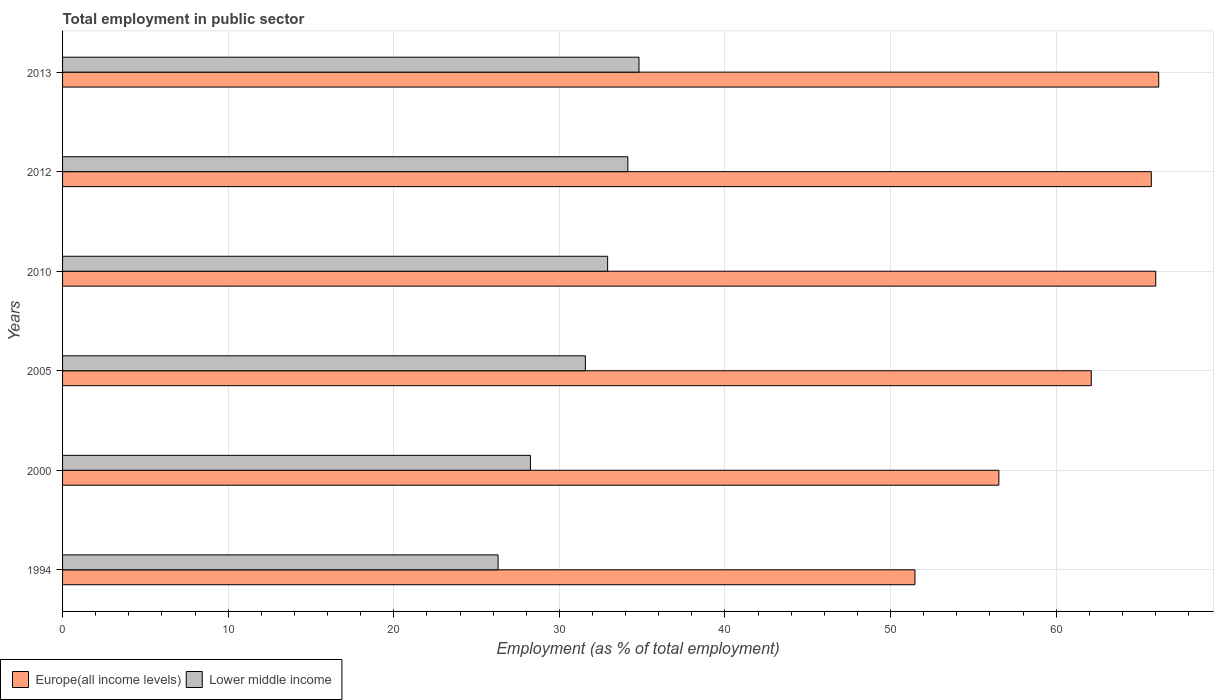How many groups of bars are there?
Make the answer very short. 6. Are the number of bars per tick equal to the number of legend labels?
Your answer should be compact. Yes. What is the employment in public sector in Europe(all income levels) in 2005?
Keep it short and to the point. 62.12. Across all years, what is the maximum employment in public sector in Europe(all income levels)?
Offer a terse response. 66.19. Across all years, what is the minimum employment in public sector in Europe(all income levels)?
Give a very brief answer. 51.47. In which year was the employment in public sector in Lower middle income maximum?
Provide a succinct answer. 2013. What is the total employment in public sector in Europe(all income levels) in the graph?
Provide a succinct answer. 368.09. What is the difference between the employment in public sector in Europe(all income levels) in 2000 and that in 2010?
Offer a terse response. -9.47. What is the difference between the employment in public sector in Europe(all income levels) in 2000 and the employment in public sector in Lower middle income in 2012?
Make the answer very short. 22.41. What is the average employment in public sector in Lower middle income per year?
Your response must be concise. 31.33. In the year 1994, what is the difference between the employment in public sector in Europe(all income levels) and employment in public sector in Lower middle income?
Make the answer very short. 25.17. What is the ratio of the employment in public sector in Europe(all income levels) in 1994 to that in 2012?
Your answer should be compact. 0.78. What is the difference between the highest and the second highest employment in public sector in Lower middle income?
Your response must be concise. 0.67. What is the difference between the highest and the lowest employment in public sector in Lower middle income?
Offer a very short reply. 8.51. In how many years, is the employment in public sector in Lower middle income greater than the average employment in public sector in Lower middle income taken over all years?
Provide a succinct answer. 4. Is the sum of the employment in public sector in Lower middle income in 2005 and 2010 greater than the maximum employment in public sector in Europe(all income levels) across all years?
Give a very brief answer. No. What does the 1st bar from the top in 2012 represents?
Keep it short and to the point. Lower middle income. What does the 1st bar from the bottom in 2012 represents?
Offer a terse response. Europe(all income levels). How many bars are there?
Make the answer very short. 12. How many years are there in the graph?
Your answer should be compact. 6. Are the values on the major ticks of X-axis written in scientific E-notation?
Your answer should be compact. No. How many legend labels are there?
Offer a very short reply. 2. What is the title of the graph?
Your answer should be compact. Total employment in public sector. Does "Cyprus" appear as one of the legend labels in the graph?
Offer a very short reply. No. What is the label or title of the X-axis?
Your answer should be very brief. Employment (as % of total employment). What is the Employment (as % of total employment) of Europe(all income levels) in 1994?
Your answer should be very brief. 51.47. What is the Employment (as % of total employment) of Lower middle income in 1994?
Offer a very short reply. 26.3. What is the Employment (as % of total employment) in Europe(all income levels) in 2000?
Provide a succinct answer. 56.54. What is the Employment (as % of total employment) in Lower middle income in 2000?
Your answer should be very brief. 28.26. What is the Employment (as % of total employment) in Europe(all income levels) in 2005?
Your response must be concise. 62.12. What is the Employment (as % of total employment) of Lower middle income in 2005?
Your answer should be very brief. 31.57. What is the Employment (as % of total employment) in Europe(all income levels) in 2010?
Your answer should be compact. 66.01. What is the Employment (as % of total employment) in Lower middle income in 2010?
Your answer should be compact. 32.92. What is the Employment (as % of total employment) in Europe(all income levels) in 2012?
Give a very brief answer. 65.75. What is the Employment (as % of total employment) in Lower middle income in 2012?
Give a very brief answer. 34.14. What is the Employment (as % of total employment) of Europe(all income levels) in 2013?
Ensure brevity in your answer.  66.19. What is the Employment (as % of total employment) in Lower middle income in 2013?
Provide a short and direct response. 34.81. Across all years, what is the maximum Employment (as % of total employment) of Europe(all income levels)?
Give a very brief answer. 66.19. Across all years, what is the maximum Employment (as % of total employment) in Lower middle income?
Your answer should be very brief. 34.81. Across all years, what is the minimum Employment (as % of total employment) of Europe(all income levels)?
Make the answer very short. 51.47. Across all years, what is the minimum Employment (as % of total employment) in Lower middle income?
Your answer should be very brief. 26.3. What is the total Employment (as % of total employment) in Europe(all income levels) in the graph?
Give a very brief answer. 368.09. What is the total Employment (as % of total employment) of Lower middle income in the graph?
Provide a short and direct response. 187.99. What is the difference between the Employment (as % of total employment) of Europe(all income levels) in 1994 and that in 2000?
Offer a very short reply. -5.07. What is the difference between the Employment (as % of total employment) in Lower middle income in 1994 and that in 2000?
Your answer should be compact. -1.96. What is the difference between the Employment (as % of total employment) of Europe(all income levels) in 1994 and that in 2005?
Keep it short and to the point. -10.65. What is the difference between the Employment (as % of total employment) of Lower middle income in 1994 and that in 2005?
Keep it short and to the point. -5.27. What is the difference between the Employment (as % of total employment) in Europe(all income levels) in 1994 and that in 2010?
Provide a short and direct response. -14.54. What is the difference between the Employment (as % of total employment) of Lower middle income in 1994 and that in 2010?
Make the answer very short. -6.62. What is the difference between the Employment (as % of total employment) of Europe(all income levels) in 1994 and that in 2012?
Provide a short and direct response. -14.27. What is the difference between the Employment (as % of total employment) of Lower middle income in 1994 and that in 2012?
Offer a terse response. -7.84. What is the difference between the Employment (as % of total employment) of Europe(all income levels) in 1994 and that in 2013?
Keep it short and to the point. -14.72. What is the difference between the Employment (as % of total employment) of Lower middle income in 1994 and that in 2013?
Make the answer very short. -8.51. What is the difference between the Employment (as % of total employment) of Europe(all income levels) in 2000 and that in 2005?
Keep it short and to the point. -5.58. What is the difference between the Employment (as % of total employment) in Lower middle income in 2000 and that in 2005?
Your response must be concise. -3.32. What is the difference between the Employment (as % of total employment) of Europe(all income levels) in 2000 and that in 2010?
Provide a succinct answer. -9.47. What is the difference between the Employment (as % of total employment) in Lower middle income in 2000 and that in 2010?
Keep it short and to the point. -4.66. What is the difference between the Employment (as % of total employment) in Europe(all income levels) in 2000 and that in 2012?
Keep it short and to the point. -9.21. What is the difference between the Employment (as % of total employment) in Lower middle income in 2000 and that in 2012?
Your answer should be compact. -5.88. What is the difference between the Employment (as % of total employment) of Europe(all income levels) in 2000 and that in 2013?
Provide a short and direct response. -9.65. What is the difference between the Employment (as % of total employment) of Lower middle income in 2000 and that in 2013?
Ensure brevity in your answer.  -6.55. What is the difference between the Employment (as % of total employment) of Europe(all income levels) in 2005 and that in 2010?
Offer a terse response. -3.89. What is the difference between the Employment (as % of total employment) in Lower middle income in 2005 and that in 2010?
Offer a very short reply. -1.34. What is the difference between the Employment (as % of total employment) in Europe(all income levels) in 2005 and that in 2012?
Make the answer very short. -3.63. What is the difference between the Employment (as % of total employment) of Lower middle income in 2005 and that in 2012?
Your response must be concise. -2.56. What is the difference between the Employment (as % of total employment) of Europe(all income levels) in 2005 and that in 2013?
Your answer should be very brief. -4.07. What is the difference between the Employment (as % of total employment) in Lower middle income in 2005 and that in 2013?
Ensure brevity in your answer.  -3.24. What is the difference between the Employment (as % of total employment) in Europe(all income levels) in 2010 and that in 2012?
Make the answer very short. 0.27. What is the difference between the Employment (as % of total employment) of Lower middle income in 2010 and that in 2012?
Keep it short and to the point. -1.22. What is the difference between the Employment (as % of total employment) in Europe(all income levels) in 2010 and that in 2013?
Make the answer very short. -0.18. What is the difference between the Employment (as % of total employment) of Lower middle income in 2010 and that in 2013?
Your response must be concise. -1.89. What is the difference between the Employment (as % of total employment) in Europe(all income levels) in 2012 and that in 2013?
Your answer should be very brief. -0.45. What is the difference between the Employment (as % of total employment) in Lower middle income in 2012 and that in 2013?
Your response must be concise. -0.67. What is the difference between the Employment (as % of total employment) of Europe(all income levels) in 1994 and the Employment (as % of total employment) of Lower middle income in 2000?
Offer a terse response. 23.22. What is the difference between the Employment (as % of total employment) in Europe(all income levels) in 1994 and the Employment (as % of total employment) in Lower middle income in 2005?
Your answer should be compact. 19.9. What is the difference between the Employment (as % of total employment) in Europe(all income levels) in 1994 and the Employment (as % of total employment) in Lower middle income in 2010?
Your answer should be compact. 18.56. What is the difference between the Employment (as % of total employment) in Europe(all income levels) in 1994 and the Employment (as % of total employment) in Lower middle income in 2012?
Offer a very short reply. 17.34. What is the difference between the Employment (as % of total employment) in Europe(all income levels) in 1994 and the Employment (as % of total employment) in Lower middle income in 2013?
Give a very brief answer. 16.66. What is the difference between the Employment (as % of total employment) of Europe(all income levels) in 2000 and the Employment (as % of total employment) of Lower middle income in 2005?
Provide a short and direct response. 24.97. What is the difference between the Employment (as % of total employment) in Europe(all income levels) in 2000 and the Employment (as % of total employment) in Lower middle income in 2010?
Keep it short and to the point. 23.63. What is the difference between the Employment (as % of total employment) of Europe(all income levels) in 2000 and the Employment (as % of total employment) of Lower middle income in 2012?
Ensure brevity in your answer.  22.41. What is the difference between the Employment (as % of total employment) of Europe(all income levels) in 2000 and the Employment (as % of total employment) of Lower middle income in 2013?
Give a very brief answer. 21.73. What is the difference between the Employment (as % of total employment) of Europe(all income levels) in 2005 and the Employment (as % of total employment) of Lower middle income in 2010?
Your response must be concise. 29.21. What is the difference between the Employment (as % of total employment) of Europe(all income levels) in 2005 and the Employment (as % of total employment) of Lower middle income in 2012?
Your answer should be very brief. 27.99. What is the difference between the Employment (as % of total employment) in Europe(all income levels) in 2005 and the Employment (as % of total employment) in Lower middle income in 2013?
Offer a terse response. 27.31. What is the difference between the Employment (as % of total employment) of Europe(all income levels) in 2010 and the Employment (as % of total employment) of Lower middle income in 2012?
Your response must be concise. 31.88. What is the difference between the Employment (as % of total employment) in Europe(all income levels) in 2010 and the Employment (as % of total employment) in Lower middle income in 2013?
Your response must be concise. 31.2. What is the difference between the Employment (as % of total employment) of Europe(all income levels) in 2012 and the Employment (as % of total employment) of Lower middle income in 2013?
Provide a succinct answer. 30.94. What is the average Employment (as % of total employment) of Europe(all income levels) per year?
Keep it short and to the point. 61.35. What is the average Employment (as % of total employment) in Lower middle income per year?
Offer a very short reply. 31.33. In the year 1994, what is the difference between the Employment (as % of total employment) in Europe(all income levels) and Employment (as % of total employment) in Lower middle income?
Offer a very short reply. 25.17. In the year 2000, what is the difference between the Employment (as % of total employment) of Europe(all income levels) and Employment (as % of total employment) of Lower middle income?
Make the answer very short. 28.29. In the year 2005, what is the difference between the Employment (as % of total employment) in Europe(all income levels) and Employment (as % of total employment) in Lower middle income?
Offer a very short reply. 30.55. In the year 2010, what is the difference between the Employment (as % of total employment) of Europe(all income levels) and Employment (as % of total employment) of Lower middle income?
Offer a terse response. 33.1. In the year 2012, what is the difference between the Employment (as % of total employment) of Europe(all income levels) and Employment (as % of total employment) of Lower middle income?
Your response must be concise. 31.61. In the year 2013, what is the difference between the Employment (as % of total employment) in Europe(all income levels) and Employment (as % of total employment) in Lower middle income?
Offer a terse response. 31.38. What is the ratio of the Employment (as % of total employment) of Europe(all income levels) in 1994 to that in 2000?
Give a very brief answer. 0.91. What is the ratio of the Employment (as % of total employment) of Lower middle income in 1994 to that in 2000?
Your response must be concise. 0.93. What is the ratio of the Employment (as % of total employment) in Europe(all income levels) in 1994 to that in 2005?
Your answer should be very brief. 0.83. What is the ratio of the Employment (as % of total employment) of Lower middle income in 1994 to that in 2005?
Offer a terse response. 0.83. What is the ratio of the Employment (as % of total employment) of Europe(all income levels) in 1994 to that in 2010?
Offer a terse response. 0.78. What is the ratio of the Employment (as % of total employment) of Lower middle income in 1994 to that in 2010?
Ensure brevity in your answer.  0.8. What is the ratio of the Employment (as % of total employment) in Europe(all income levels) in 1994 to that in 2012?
Offer a very short reply. 0.78. What is the ratio of the Employment (as % of total employment) of Lower middle income in 1994 to that in 2012?
Your answer should be compact. 0.77. What is the ratio of the Employment (as % of total employment) in Europe(all income levels) in 1994 to that in 2013?
Make the answer very short. 0.78. What is the ratio of the Employment (as % of total employment) of Lower middle income in 1994 to that in 2013?
Make the answer very short. 0.76. What is the ratio of the Employment (as % of total employment) in Europe(all income levels) in 2000 to that in 2005?
Offer a very short reply. 0.91. What is the ratio of the Employment (as % of total employment) of Lower middle income in 2000 to that in 2005?
Your answer should be very brief. 0.9. What is the ratio of the Employment (as % of total employment) in Europe(all income levels) in 2000 to that in 2010?
Provide a short and direct response. 0.86. What is the ratio of the Employment (as % of total employment) in Lower middle income in 2000 to that in 2010?
Your answer should be very brief. 0.86. What is the ratio of the Employment (as % of total employment) in Europe(all income levels) in 2000 to that in 2012?
Offer a very short reply. 0.86. What is the ratio of the Employment (as % of total employment) in Lower middle income in 2000 to that in 2012?
Ensure brevity in your answer.  0.83. What is the ratio of the Employment (as % of total employment) of Europe(all income levels) in 2000 to that in 2013?
Offer a very short reply. 0.85. What is the ratio of the Employment (as % of total employment) in Lower middle income in 2000 to that in 2013?
Make the answer very short. 0.81. What is the ratio of the Employment (as % of total employment) in Europe(all income levels) in 2005 to that in 2010?
Offer a very short reply. 0.94. What is the ratio of the Employment (as % of total employment) of Lower middle income in 2005 to that in 2010?
Provide a succinct answer. 0.96. What is the ratio of the Employment (as % of total employment) of Europe(all income levels) in 2005 to that in 2012?
Your response must be concise. 0.94. What is the ratio of the Employment (as % of total employment) in Lower middle income in 2005 to that in 2012?
Give a very brief answer. 0.92. What is the ratio of the Employment (as % of total employment) in Europe(all income levels) in 2005 to that in 2013?
Give a very brief answer. 0.94. What is the ratio of the Employment (as % of total employment) of Lower middle income in 2005 to that in 2013?
Offer a terse response. 0.91. What is the ratio of the Employment (as % of total employment) of Europe(all income levels) in 2010 to that in 2012?
Your answer should be compact. 1. What is the ratio of the Employment (as % of total employment) of Lower middle income in 2010 to that in 2012?
Offer a terse response. 0.96. What is the ratio of the Employment (as % of total employment) in Lower middle income in 2010 to that in 2013?
Keep it short and to the point. 0.95. What is the ratio of the Employment (as % of total employment) of Europe(all income levels) in 2012 to that in 2013?
Make the answer very short. 0.99. What is the ratio of the Employment (as % of total employment) of Lower middle income in 2012 to that in 2013?
Ensure brevity in your answer.  0.98. What is the difference between the highest and the second highest Employment (as % of total employment) of Europe(all income levels)?
Your answer should be compact. 0.18. What is the difference between the highest and the second highest Employment (as % of total employment) in Lower middle income?
Provide a short and direct response. 0.67. What is the difference between the highest and the lowest Employment (as % of total employment) of Europe(all income levels)?
Give a very brief answer. 14.72. What is the difference between the highest and the lowest Employment (as % of total employment) in Lower middle income?
Provide a succinct answer. 8.51. 